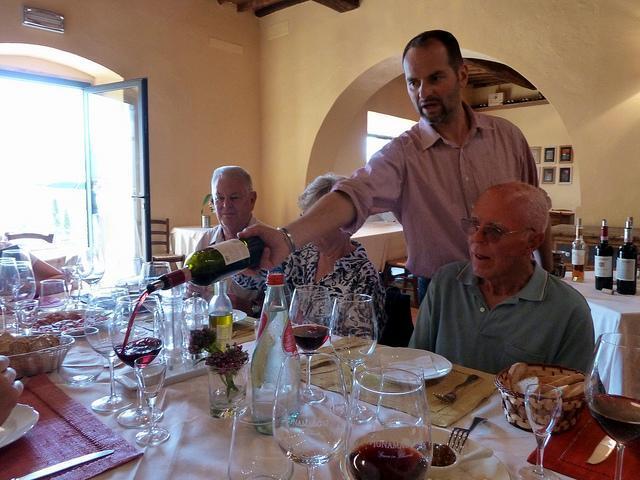How many wine glasses are visible?
Give a very brief answer. 11. How many people can be seen?
Give a very brief answer. 4. How many dining tables are there?
Give a very brief answer. 2. How many bottles are there?
Give a very brief answer. 2. 